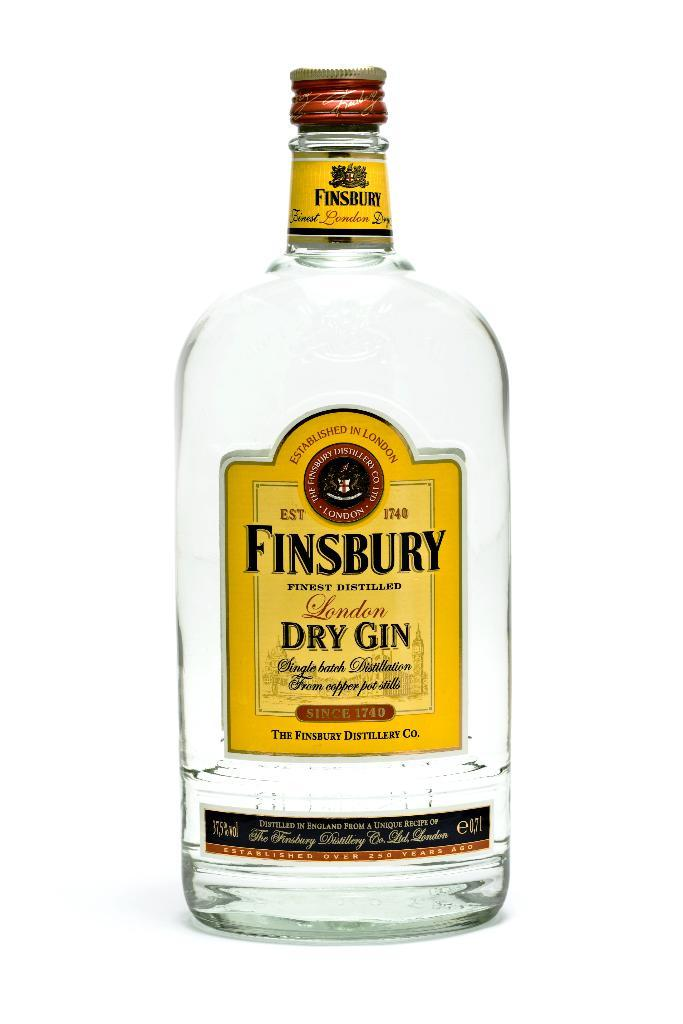<image>
Provide a brief description of the given image. Completely empty bottle of Finsbury dry gin in a white background. 